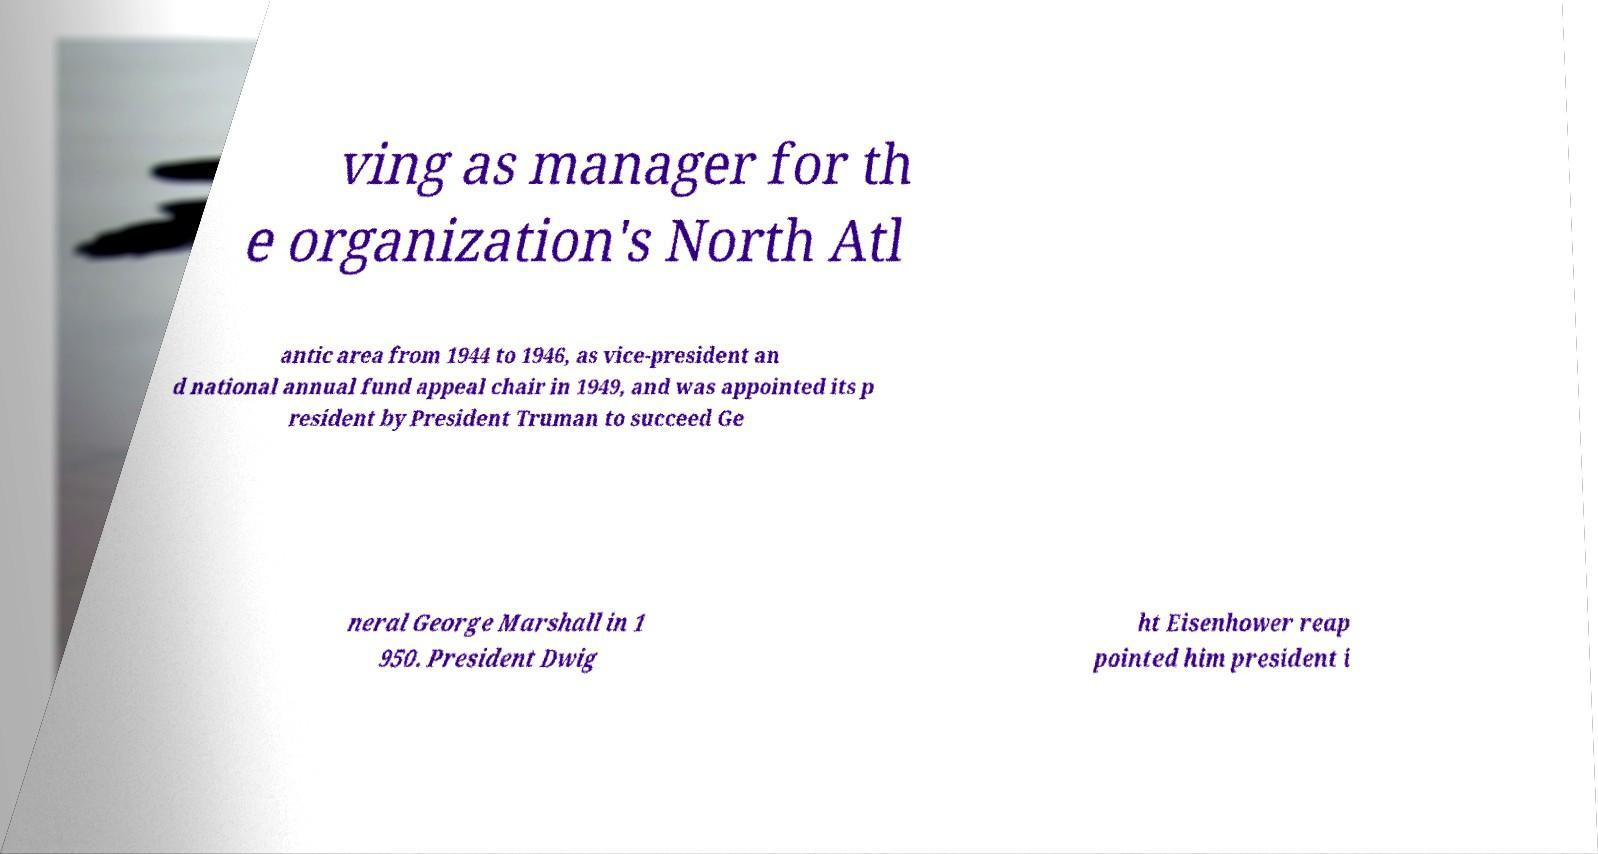There's text embedded in this image that I need extracted. Can you transcribe it verbatim? ving as manager for th e organization's North Atl antic area from 1944 to 1946, as vice-president an d national annual fund appeal chair in 1949, and was appointed its p resident by President Truman to succeed Ge neral George Marshall in 1 950. President Dwig ht Eisenhower reap pointed him president i 